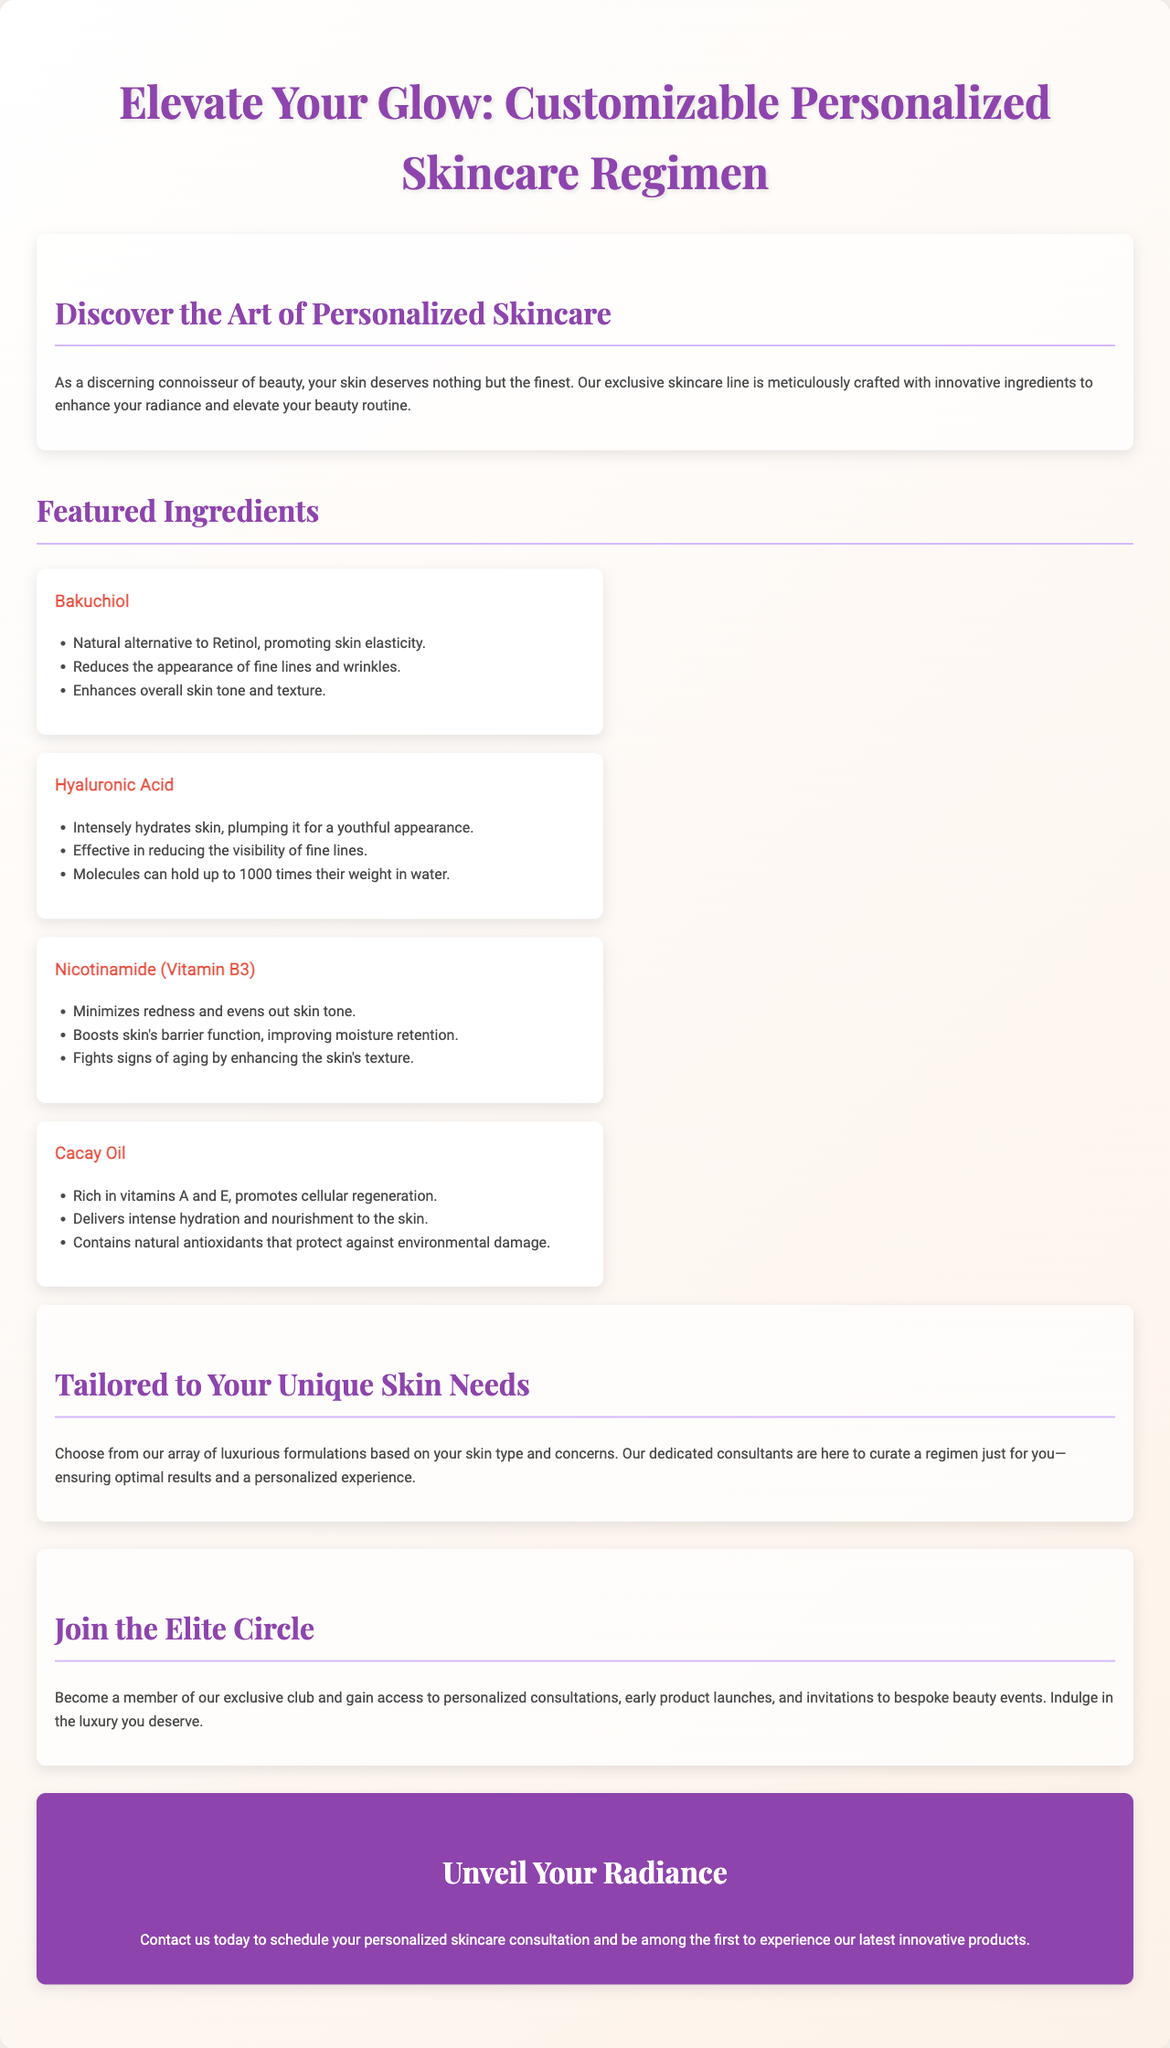What is the title of the brochure? The title is prominently displayed at the top of the document, which is "Elevate Your Glow: Customizable Personalized Skincare Regimen."
Answer: Elevate Your Glow: Customizable Personalized Skincare Regimen How many featured ingredients are listed? The document lists four featured ingredients under the "Featured Ingredients" section.
Answer: Four What ingredient is a natural alternative to Retinol? The ingredient that serves as a natural alternative to Retinol is mentioned in its description.
Answer: Bakuchiol What benefit does Hyaluronic Acid provide? The document states that Hyaluronic Acid "intensely hydrates skin, plumping it for a youthful appearance."
Answer: Intensely hydrates skin What is one of the advantages of joining the exclusive circle? The document highlights benefits for members of the exclusive circle, including access to early product launches.
Answer: Early product launches What mission statement can be inferred from the brochure? The brochure emphasizes the customization of skincare regimens tailored to individual skin needs and desires.
Answer: Tailored to Your Unique Skin Needs Which ingredient is rich in vitamins A and E? The ingredient with high vitamin content is specifically noted in the features listed within the document.
Answer: Cacay Oil 